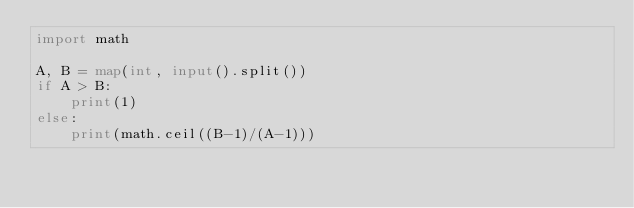<code> <loc_0><loc_0><loc_500><loc_500><_Python_>import math

A, B = map(int, input().split())
if A > B:
    print(1)
else:
    print(math.ceil((B-1)/(A-1)))</code> 